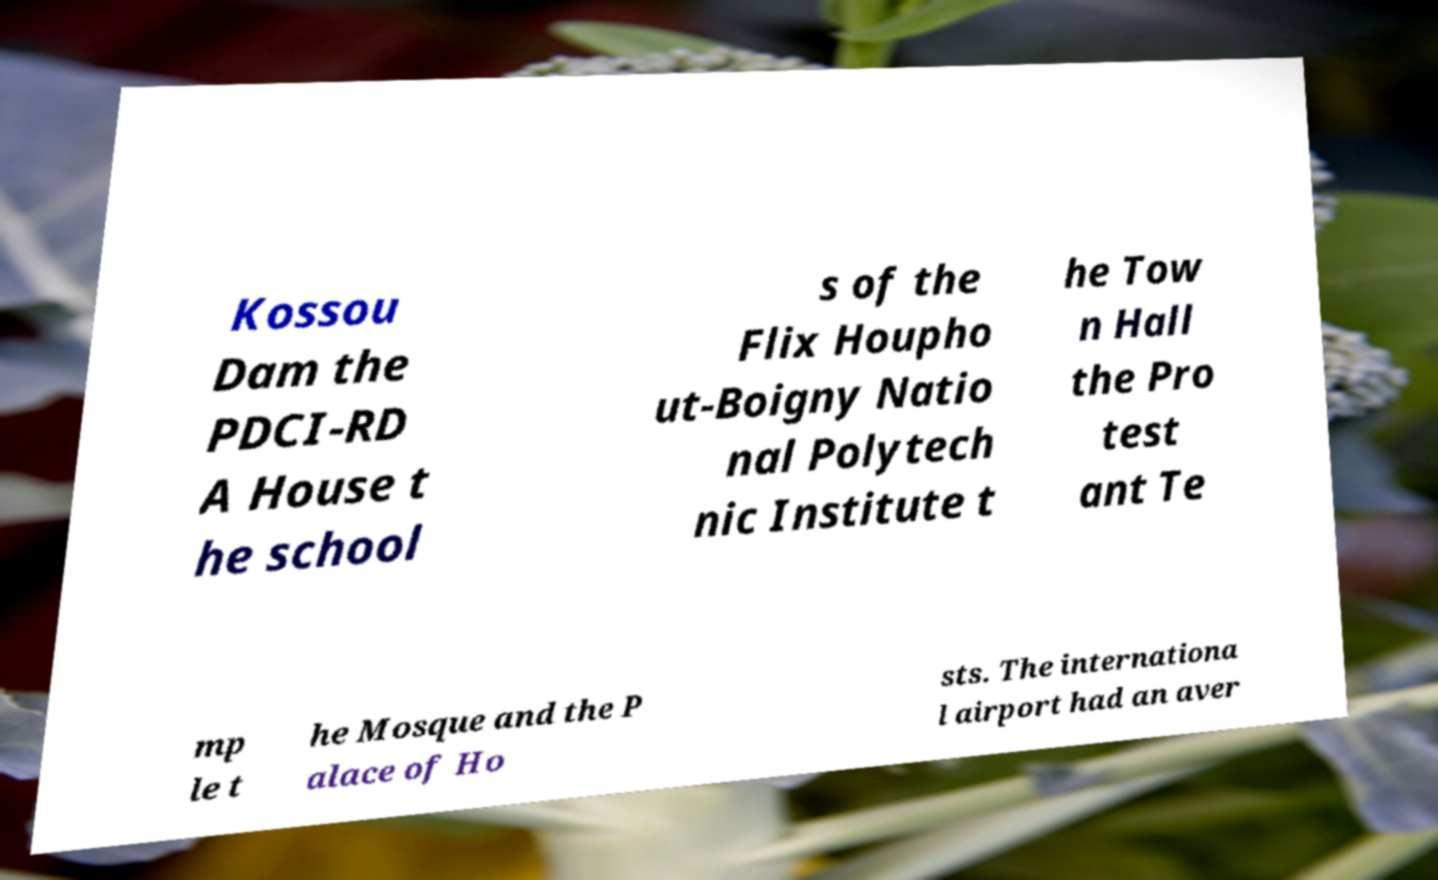For documentation purposes, I need the text within this image transcribed. Could you provide that? Kossou Dam the PDCI-RD A House t he school s of the Flix Houpho ut-Boigny Natio nal Polytech nic Institute t he Tow n Hall the Pro test ant Te mp le t he Mosque and the P alace of Ho sts. The internationa l airport had an aver 